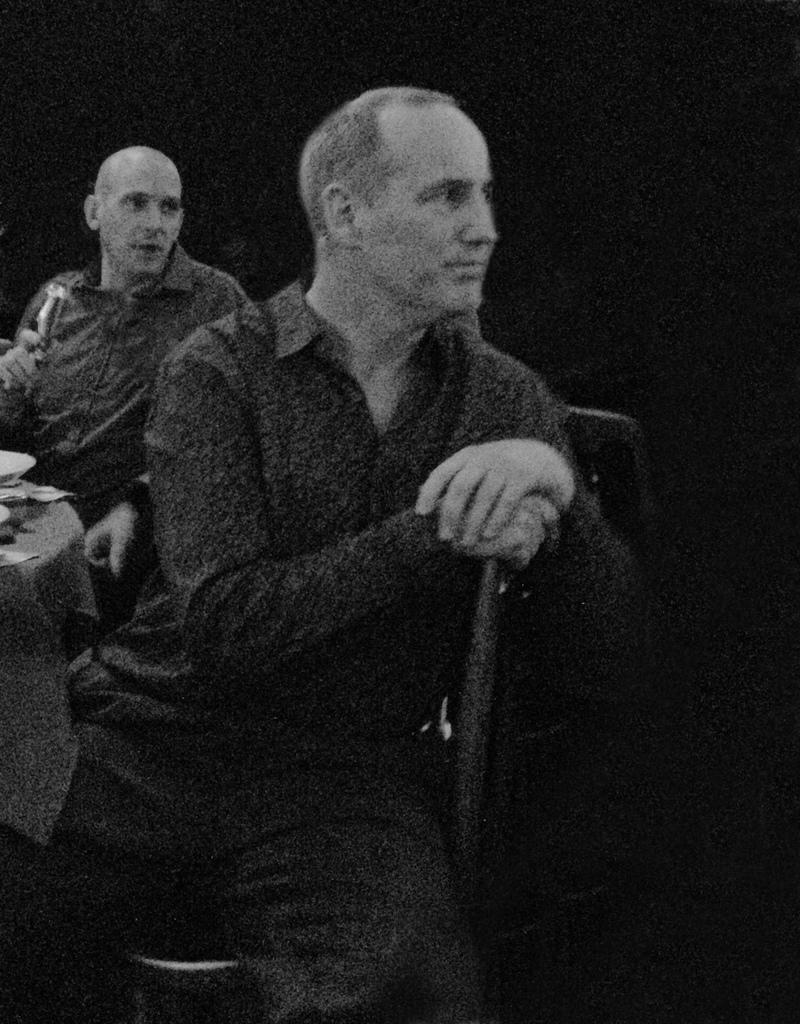What are the people in the image doing? The people in the image are sitting on chairs. What is located in front of the chairs? There is a table in front of the chairs. What can be seen on top of the table? There are objects on top of the table. What type of hydrant is visible in the image? There is no hydrant present in the image. How does the rest of the room look like in the image? The provided facts do not give information about the rest of the room, so we cannot answer this question. 